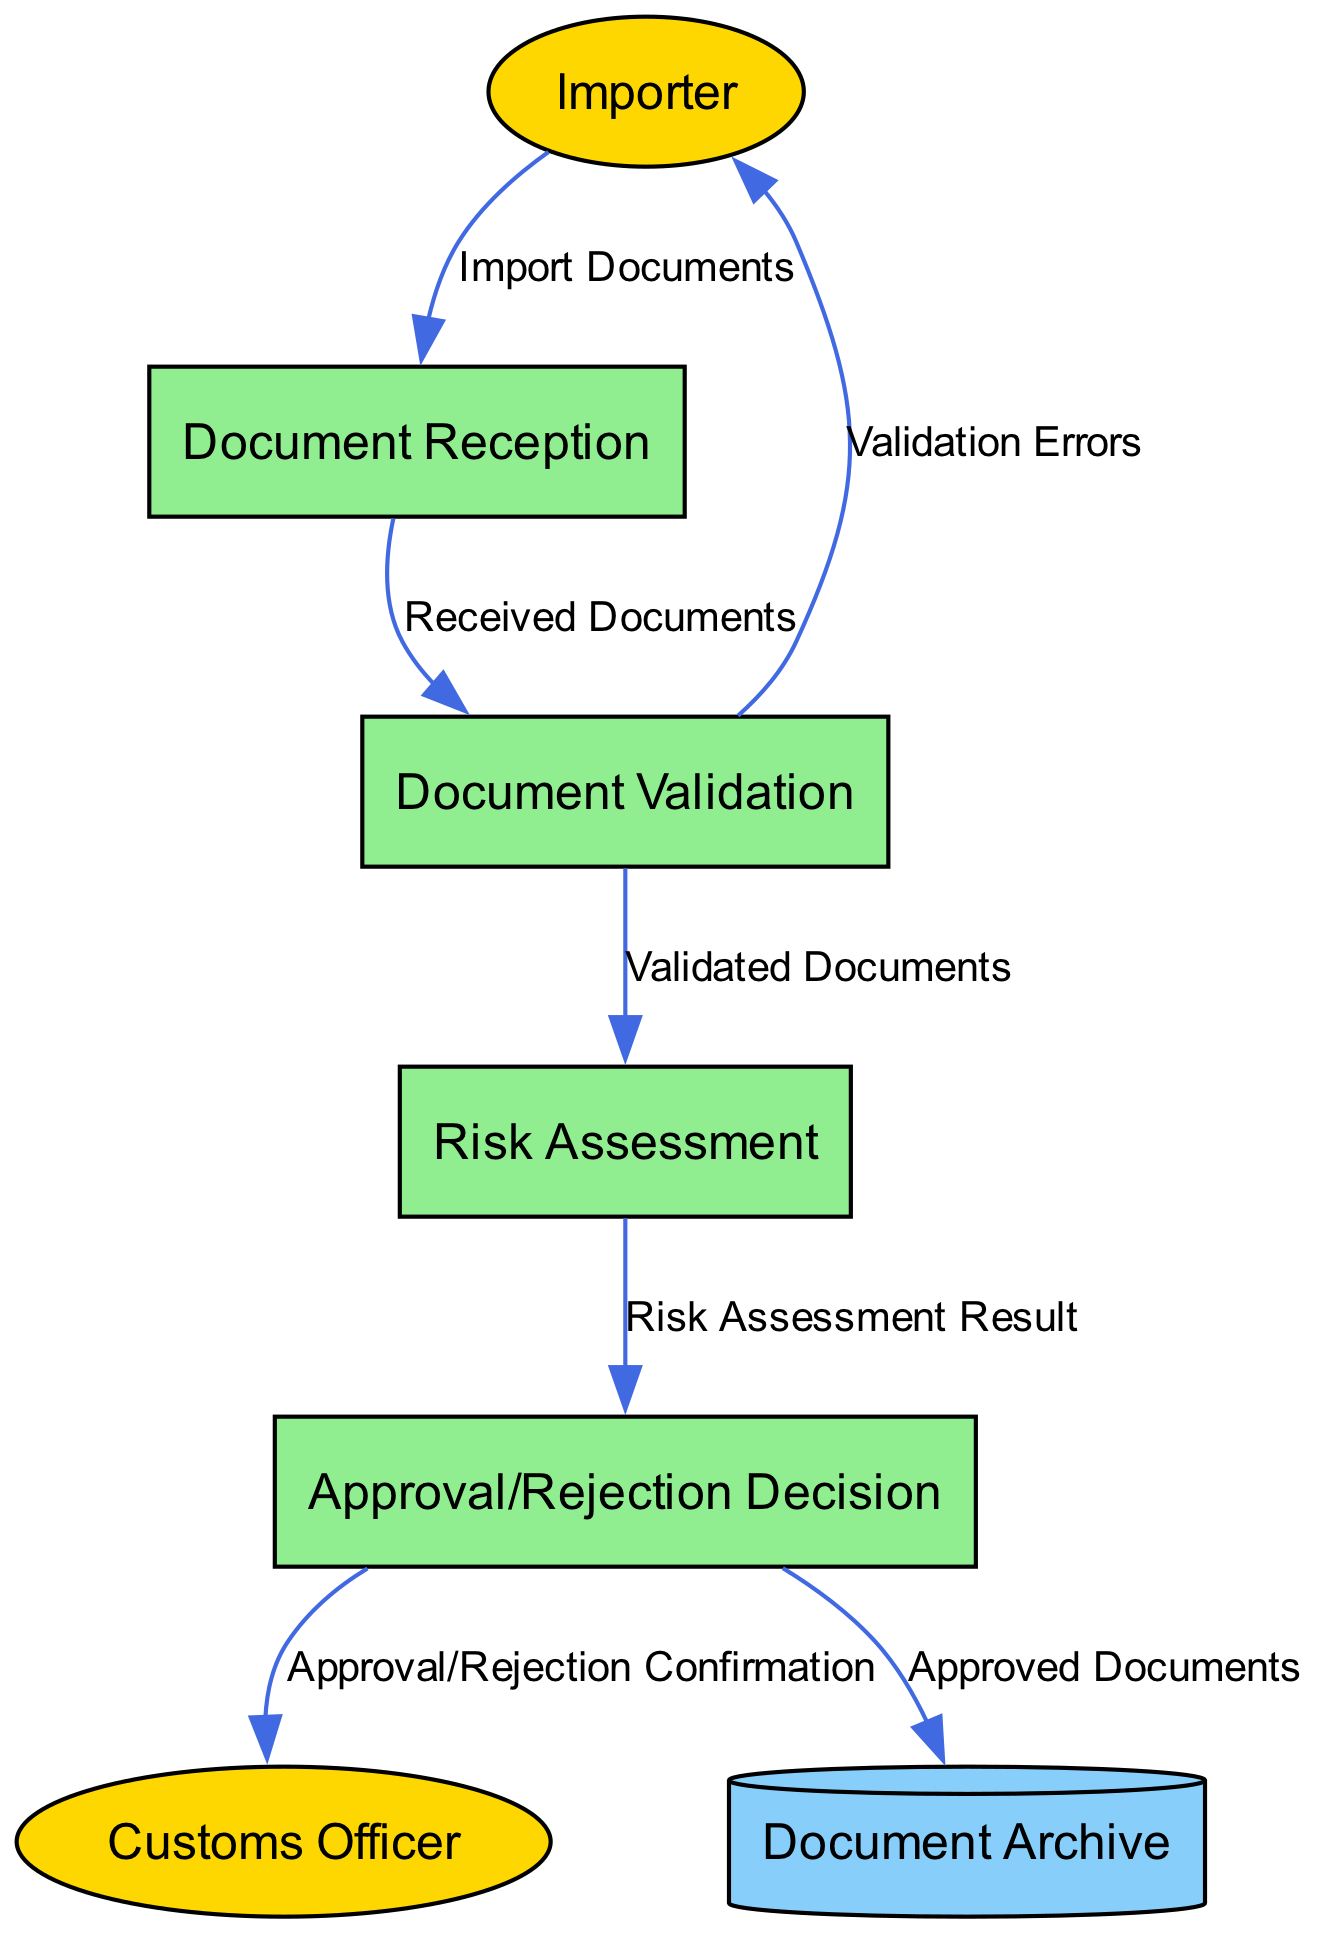What is the first process in the diagram? The first process in the diagram is "Document Reception," where import documents are initially received and logged. This can be deduced as it directly follows the data flow from the "Importer" entity.
Answer: Document Reception How many external entities are present in the diagram? The diagram includes two external entities: "Importer" and "Customs Officer.” They are identified by the entity types described in the diagram.
Answer: 2 What type of data flows from "Document Validation" to "Importer"? The type of data flowing from "Document Validation" to "Importer" is "Validation Errors." This is noted in the data flows section where it specifies what data moves between these two nodes.
Answer: Validation Errors Which process follows the "Risk Assessment" process? The process that follows "Risk Assessment" is "Approval/Rejection Decision." This is determined by evaluating the sequence of data flows leading from "Risk Assessment."
Answer: Approval/Rejection Decision What data is sent from "Approval/Rejection Decision" to "Document Archive"? The data sent from "Approval/Rejection Decision" to "Document Archive" is "Approved Documents." This can be found in the data flows that connect these two specific nodes.
Answer: Approved Documents Which entity receives a confirmation from the "Approval/Rejection Decision"? The entity receiving a confirmation from the "Approval/Rejection Decision" is the "Customs Officer." In the data flows, it's shown that this confirmation specifically goes to the Customs Officer after the decision is made.
Answer: Customs Officer What is the last action taken after document approval? The last action taken after document approval is storing the "Approved Documents" in the "Document Archive." This follows logically after the decision process, indicating the final disposition of approved documents.
Answer: Document Archive How many processes are depicted in the diagram? The diagram depicts four processes: "Document Reception," "Document Validation," "Risk Assessment," and "Approval/Rejection Decision." Each process can be identified from the entities section and counted.
Answer: 4 What is the main purpose of the "Risk Assessment" process? The main purpose of the "Risk Assessment" process is to evaluate documents for potential compliance risks. This is outlined in the description of the process, indicating its primary function within the verification workflow.
Answer: Evaluate compliance risks 